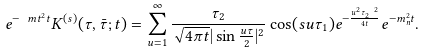<formula> <loc_0><loc_0><loc_500><loc_500>e ^ { - \ m t ^ { 2 } t } K ^ { ( s ) } ( \tau , \bar { \tau } ; t ) = \sum _ { u = 1 } ^ { \infty } \frac { \tau _ { 2 } } { \sqrt { 4 \pi t } | \sin \frac { u \tau } { 2 } | ^ { 2 } } \cos ( s u \tau _ { 1 } ) e ^ { - \frac { u ^ { 2 } \tau _ { 2 } ^ { \ 2 } } { 4 t } } e ^ { - m _ { n } ^ { 2 } t } .</formula> 